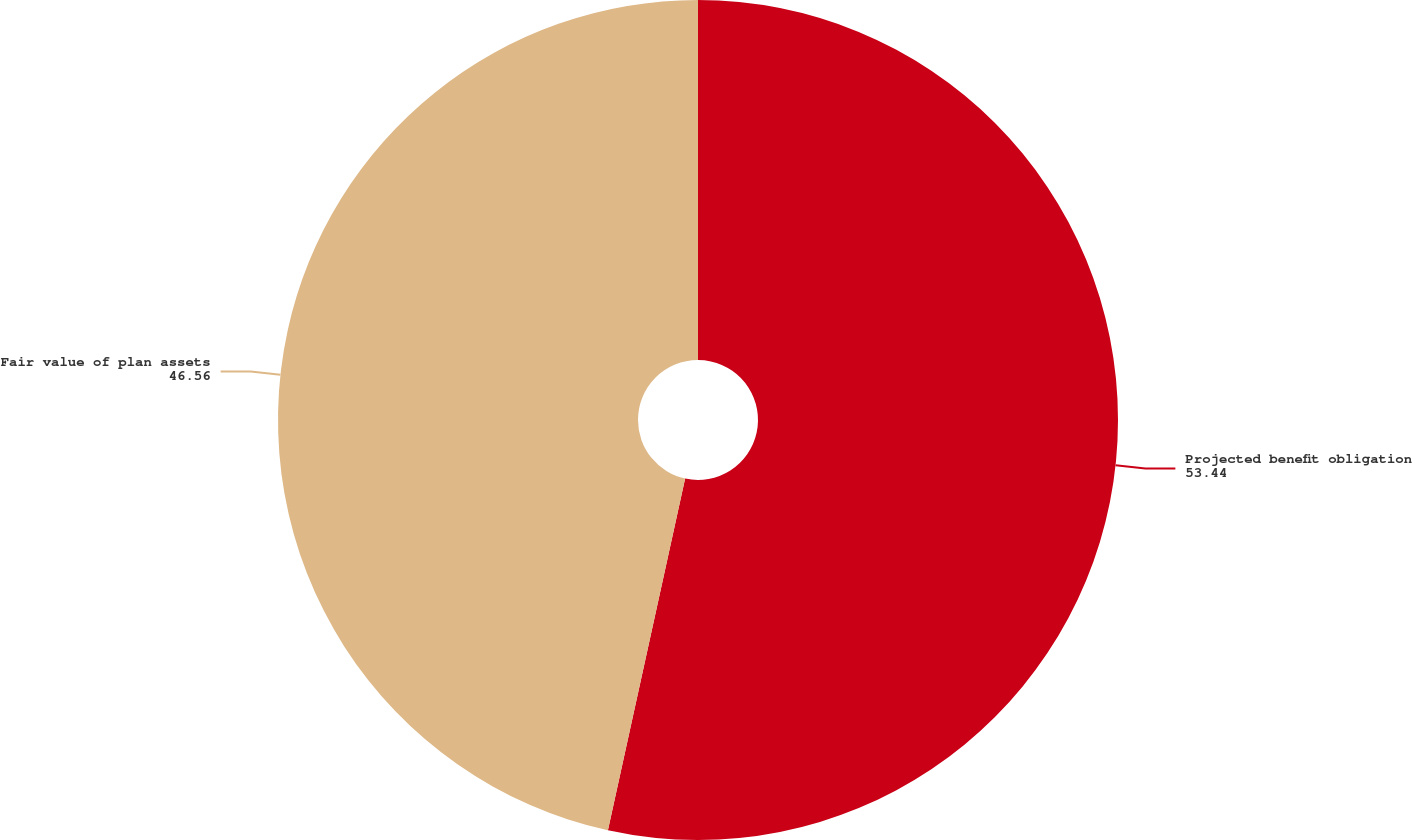Convert chart. <chart><loc_0><loc_0><loc_500><loc_500><pie_chart><fcel>Projected benefit obligation<fcel>Fair value of plan assets<nl><fcel>53.44%<fcel>46.56%<nl></chart> 